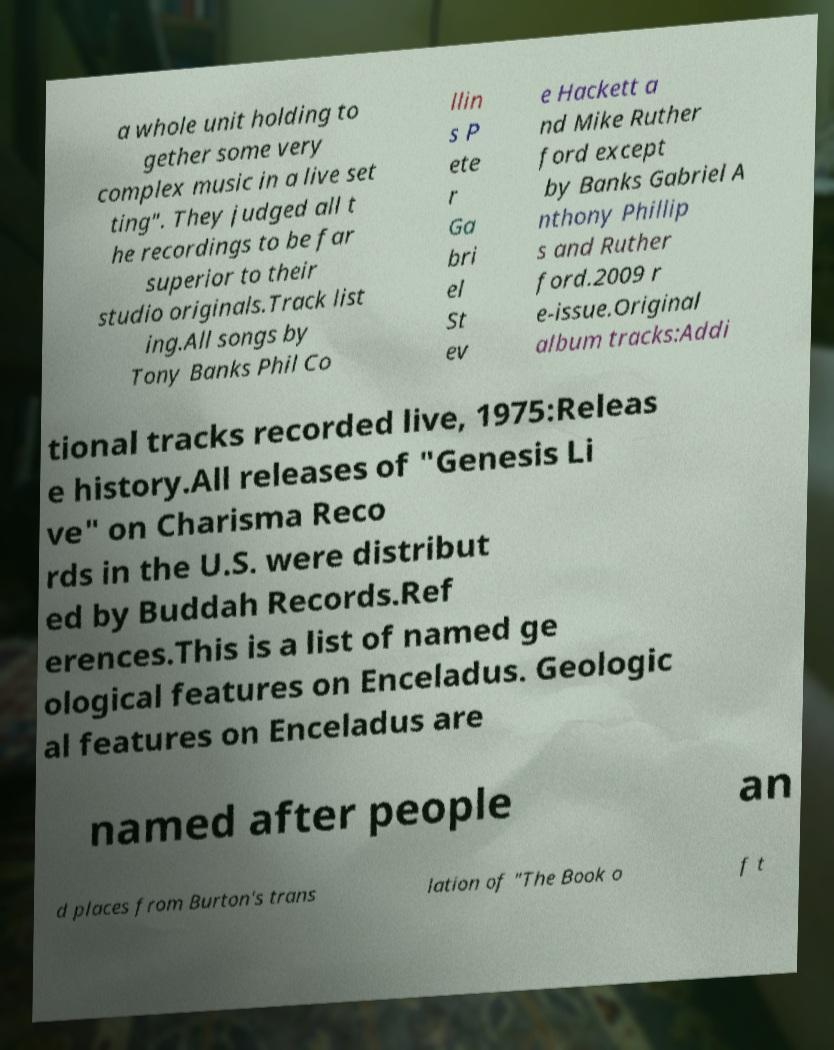What messages or text are displayed in this image? I need them in a readable, typed format. a whole unit holding to gether some very complex music in a live set ting". They judged all t he recordings to be far superior to their studio originals.Track list ing.All songs by Tony Banks Phil Co llin s P ete r Ga bri el St ev e Hackett a nd Mike Ruther ford except by Banks Gabriel A nthony Phillip s and Ruther ford.2009 r e-issue.Original album tracks:Addi tional tracks recorded live, 1975:Releas e history.All releases of "Genesis Li ve" on Charisma Reco rds in the U.S. were distribut ed by Buddah Records.Ref erences.This is a list of named ge ological features on Enceladus. Geologic al features on Enceladus are named after people an d places from Burton's trans lation of "The Book o f t 